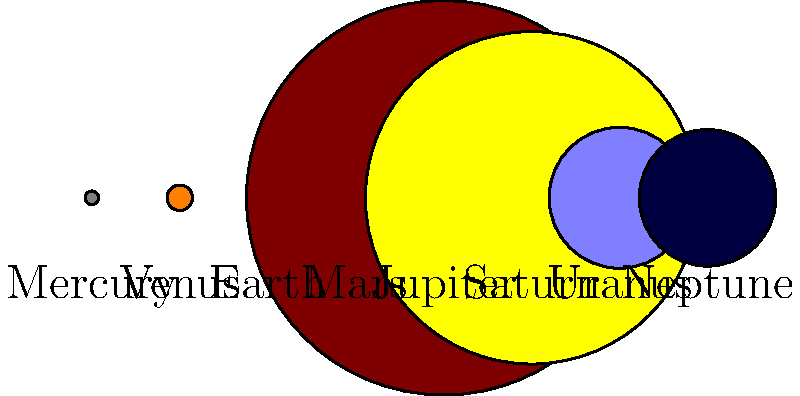Dans l'image, les planètes de notre système solaire sont représentées par des cercles à l'échelle. Quelle planète est environ 11 fois plus grande que la Terre en diamètre ? Pour répondre à cette question, suivons ces étapes :

1. Observons que la Terre est représentée par un cercle bleu.
2. Comparons visuellement les tailles des autres planètes à celle de la Terre.
3. Nous remarquons que deux planètes sont significativement plus grandes que les autres : Jupiter (brune) et Saturne (jaune).
4. En examinant de plus près, nous voyons que Jupiter est légèrement plus grande que Saturne.
5. Pour confirmer, regardons les valeurs de rayon dans le code Asymptote :
   - Terre : 1
   - Jupiter : 11.209
6. Le rapport entre le rayon de Jupiter et celui de la Terre est d'environ 11.209, ce qui correspond à "environ 11 fois plus grande".

Donc, la planète qui est environ 11 fois plus grande que la Terre en diamètre est Jupiter.
Answer: Jupiter 